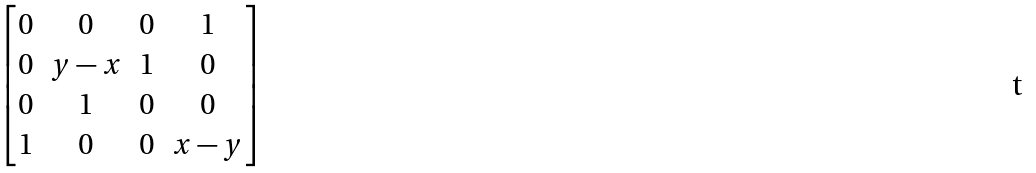<formula> <loc_0><loc_0><loc_500><loc_500>\begin{bmatrix} 0 & 0 & 0 & 1 \\ 0 & y - x & 1 & 0 \\ 0 & 1 & 0 & 0 \\ 1 & 0 & 0 & x - y \end{bmatrix}</formula> 